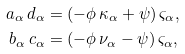<formula> <loc_0><loc_0><loc_500><loc_500>a _ { \alpha } \, d _ { \alpha } & = ( - \phi \, \kappa _ { \alpha } + \psi ) \, \varsigma _ { \alpha } , \\ b _ { \alpha } \, c _ { \alpha } & = ( - \phi \, \nu _ { \alpha } - \psi ) \, \varsigma _ { \alpha } ,</formula> 